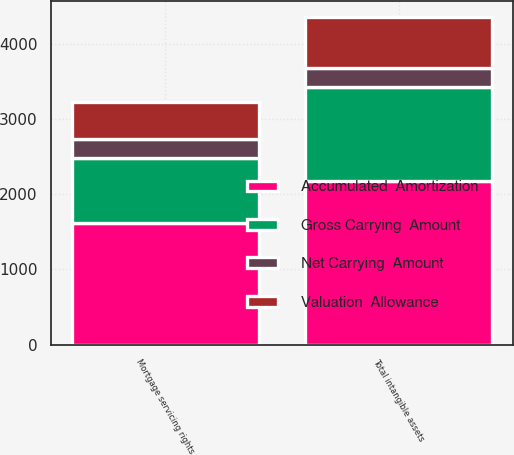Convert chart. <chart><loc_0><loc_0><loc_500><loc_500><stacked_bar_chart><ecel><fcel>Mortgage servicing rights<fcel>Total intangible assets<nl><fcel>Accumulated  Amortization<fcel>1614<fcel>2175<nl><fcel>Gross Carrying  Amount<fcel>862<fcel>1252<nl><fcel>Net Carrying  Amount<fcel>256<fcel>256<nl><fcel>Valuation  Allowance<fcel>496<fcel>667<nl></chart> 